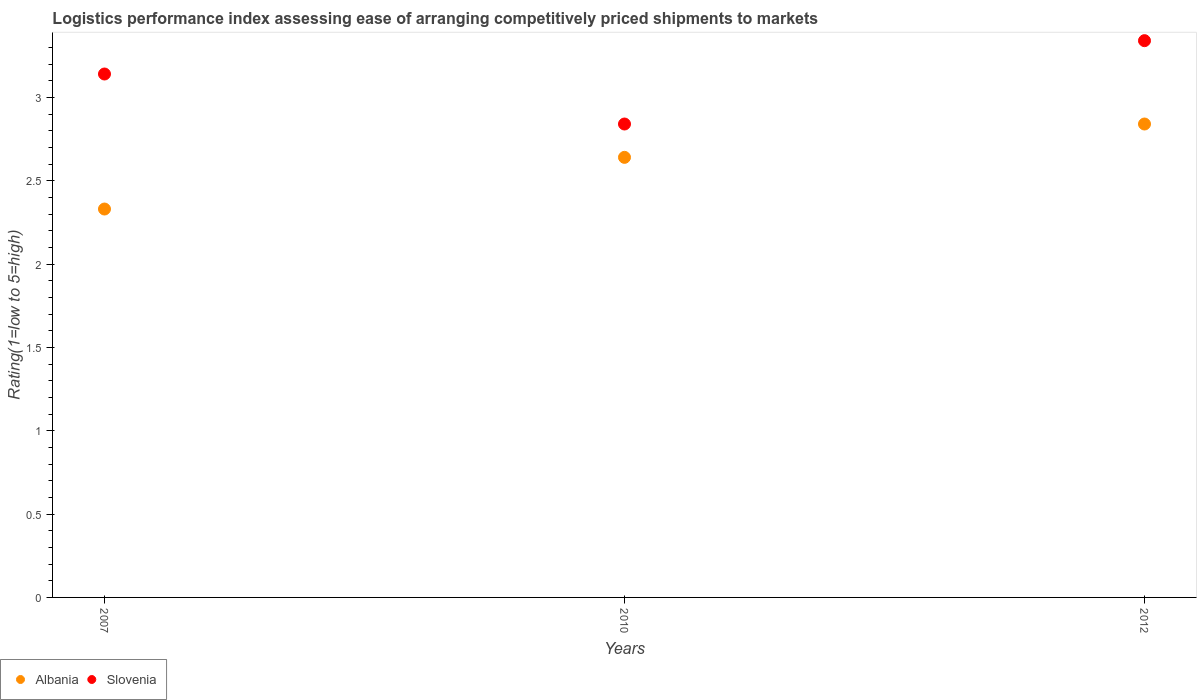How many different coloured dotlines are there?
Your answer should be very brief. 2. Is the number of dotlines equal to the number of legend labels?
Your answer should be compact. Yes. What is the Logistic performance index in Albania in 2010?
Offer a terse response. 2.64. Across all years, what is the maximum Logistic performance index in Slovenia?
Keep it short and to the point. 3.34. Across all years, what is the minimum Logistic performance index in Albania?
Keep it short and to the point. 2.33. In which year was the Logistic performance index in Albania maximum?
Keep it short and to the point. 2012. In which year was the Logistic performance index in Slovenia minimum?
Keep it short and to the point. 2010. What is the total Logistic performance index in Slovenia in the graph?
Keep it short and to the point. 9.32. What is the difference between the Logistic performance index in Slovenia in 2007 and that in 2010?
Give a very brief answer. 0.3. What is the difference between the Logistic performance index in Albania in 2010 and the Logistic performance index in Slovenia in 2012?
Keep it short and to the point. -0.7. What is the average Logistic performance index in Albania per year?
Offer a terse response. 2.6. In the year 2007, what is the difference between the Logistic performance index in Albania and Logistic performance index in Slovenia?
Your response must be concise. -0.81. What is the ratio of the Logistic performance index in Albania in 2007 to that in 2012?
Give a very brief answer. 0.82. Is the Logistic performance index in Albania in 2007 less than that in 2010?
Keep it short and to the point. Yes. What is the difference between the highest and the second highest Logistic performance index in Albania?
Offer a very short reply. 0.2. What is the difference between the highest and the lowest Logistic performance index in Albania?
Your response must be concise. 0.51. In how many years, is the Logistic performance index in Slovenia greater than the average Logistic performance index in Slovenia taken over all years?
Ensure brevity in your answer.  2. Is the sum of the Logistic performance index in Albania in 2007 and 2010 greater than the maximum Logistic performance index in Slovenia across all years?
Keep it short and to the point. Yes. Does the Logistic performance index in Slovenia monotonically increase over the years?
Offer a terse response. No. Is the Logistic performance index in Slovenia strictly less than the Logistic performance index in Albania over the years?
Provide a succinct answer. No. How many dotlines are there?
Offer a terse response. 2. How many years are there in the graph?
Keep it short and to the point. 3. Does the graph contain any zero values?
Offer a very short reply. No. Where does the legend appear in the graph?
Offer a very short reply. Bottom left. How many legend labels are there?
Offer a very short reply. 2. What is the title of the graph?
Keep it short and to the point. Logistics performance index assessing ease of arranging competitively priced shipments to markets. Does "Latin America(all income levels)" appear as one of the legend labels in the graph?
Offer a very short reply. No. What is the label or title of the X-axis?
Keep it short and to the point. Years. What is the label or title of the Y-axis?
Make the answer very short. Rating(1=low to 5=high). What is the Rating(1=low to 5=high) of Albania in 2007?
Give a very brief answer. 2.33. What is the Rating(1=low to 5=high) of Slovenia in 2007?
Your answer should be compact. 3.14. What is the Rating(1=low to 5=high) in Albania in 2010?
Provide a short and direct response. 2.64. What is the Rating(1=low to 5=high) in Slovenia in 2010?
Keep it short and to the point. 2.84. What is the Rating(1=low to 5=high) of Albania in 2012?
Offer a terse response. 2.84. What is the Rating(1=low to 5=high) in Slovenia in 2012?
Your answer should be compact. 3.34. Across all years, what is the maximum Rating(1=low to 5=high) of Albania?
Make the answer very short. 2.84. Across all years, what is the maximum Rating(1=low to 5=high) in Slovenia?
Provide a short and direct response. 3.34. Across all years, what is the minimum Rating(1=low to 5=high) in Albania?
Your answer should be compact. 2.33. Across all years, what is the minimum Rating(1=low to 5=high) of Slovenia?
Your response must be concise. 2.84. What is the total Rating(1=low to 5=high) in Albania in the graph?
Your answer should be compact. 7.81. What is the total Rating(1=low to 5=high) in Slovenia in the graph?
Your answer should be compact. 9.32. What is the difference between the Rating(1=low to 5=high) in Albania in 2007 and that in 2010?
Give a very brief answer. -0.31. What is the difference between the Rating(1=low to 5=high) of Slovenia in 2007 and that in 2010?
Your answer should be compact. 0.3. What is the difference between the Rating(1=low to 5=high) in Albania in 2007 and that in 2012?
Keep it short and to the point. -0.51. What is the difference between the Rating(1=low to 5=high) in Slovenia in 2007 and that in 2012?
Ensure brevity in your answer.  -0.2. What is the difference between the Rating(1=low to 5=high) of Slovenia in 2010 and that in 2012?
Ensure brevity in your answer.  -0.5. What is the difference between the Rating(1=low to 5=high) of Albania in 2007 and the Rating(1=low to 5=high) of Slovenia in 2010?
Offer a terse response. -0.51. What is the difference between the Rating(1=low to 5=high) of Albania in 2007 and the Rating(1=low to 5=high) of Slovenia in 2012?
Give a very brief answer. -1.01. What is the average Rating(1=low to 5=high) in Albania per year?
Your answer should be very brief. 2.6. What is the average Rating(1=low to 5=high) of Slovenia per year?
Give a very brief answer. 3.11. In the year 2007, what is the difference between the Rating(1=low to 5=high) of Albania and Rating(1=low to 5=high) of Slovenia?
Make the answer very short. -0.81. In the year 2010, what is the difference between the Rating(1=low to 5=high) of Albania and Rating(1=low to 5=high) of Slovenia?
Your answer should be very brief. -0.2. What is the ratio of the Rating(1=low to 5=high) in Albania in 2007 to that in 2010?
Offer a very short reply. 0.88. What is the ratio of the Rating(1=low to 5=high) of Slovenia in 2007 to that in 2010?
Provide a succinct answer. 1.11. What is the ratio of the Rating(1=low to 5=high) in Albania in 2007 to that in 2012?
Your answer should be compact. 0.82. What is the ratio of the Rating(1=low to 5=high) of Slovenia in 2007 to that in 2012?
Offer a very short reply. 0.94. What is the ratio of the Rating(1=low to 5=high) of Albania in 2010 to that in 2012?
Offer a very short reply. 0.93. What is the ratio of the Rating(1=low to 5=high) in Slovenia in 2010 to that in 2012?
Your answer should be very brief. 0.85. What is the difference between the highest and the second highest Rating(1=low to 5=high) of Albania?
Your response must be concise. 0.2. What is the difference between the highest and the lowest Rating(1=low to 5=high) in Albania?
Your response must be concise. 0.51. What is the difference between the highest and the lowest Rating(1=low to 5=high) in Slovenia?
Offer a very short reply. 0.5. 